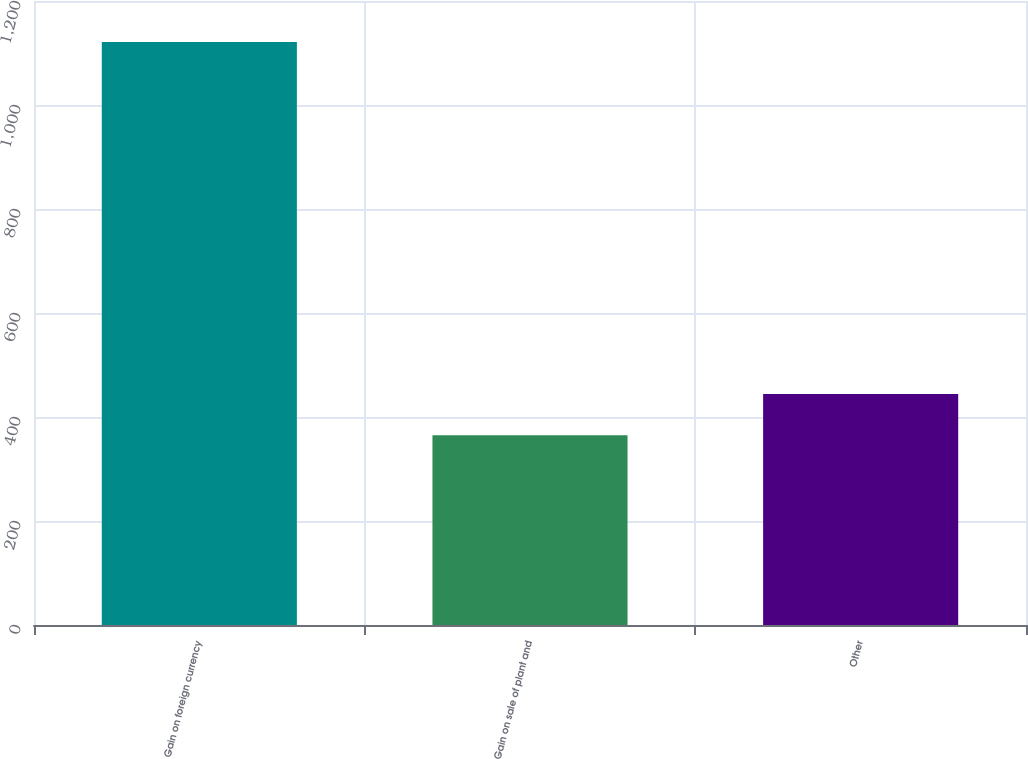Convert chart to OTSL. <chart><loc_0><loc_0><loc_500><loc_500><bar_chart><fcel>Gain on foreign currency<fcel>Gain on sale of plant and<fcel>Other<nl><fcel>1121<fcel>365<fcel>444<nl></chart> 